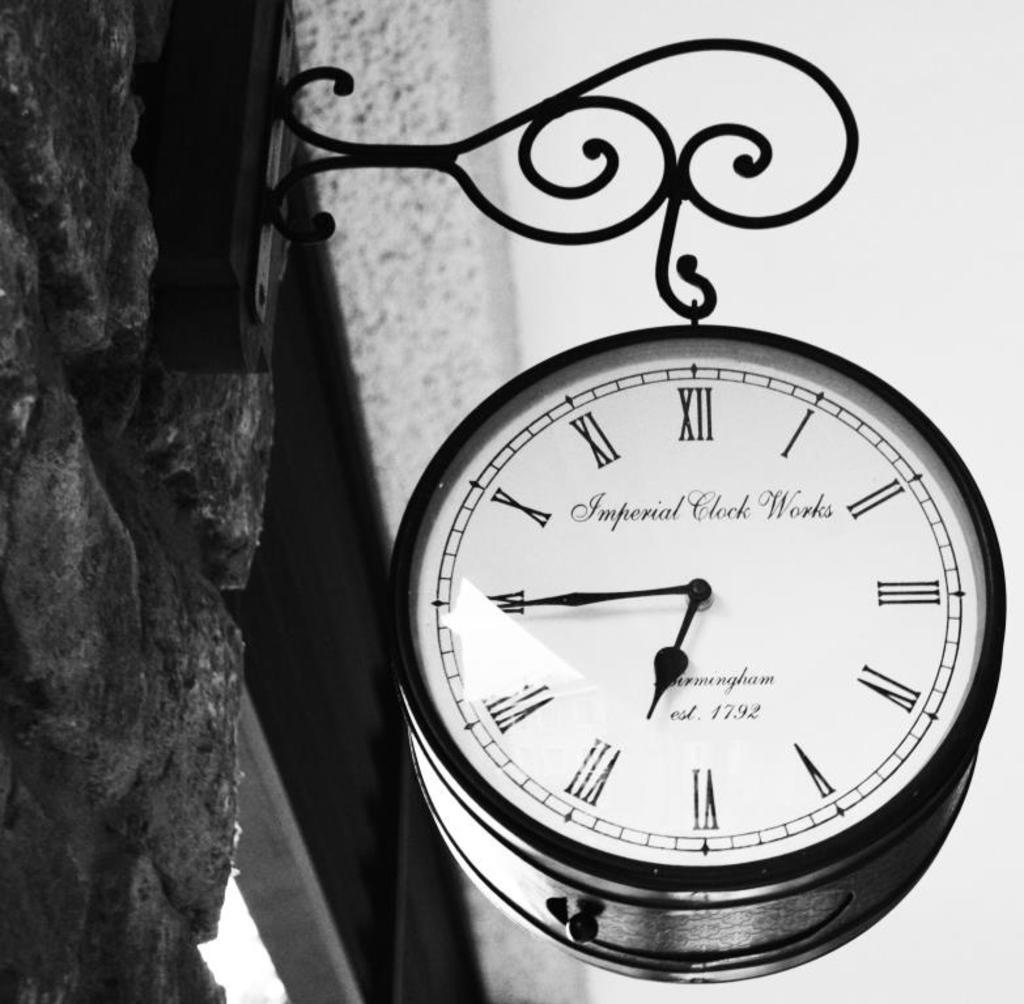When was this clock company established?
Provide a short and direct response. 1792. 